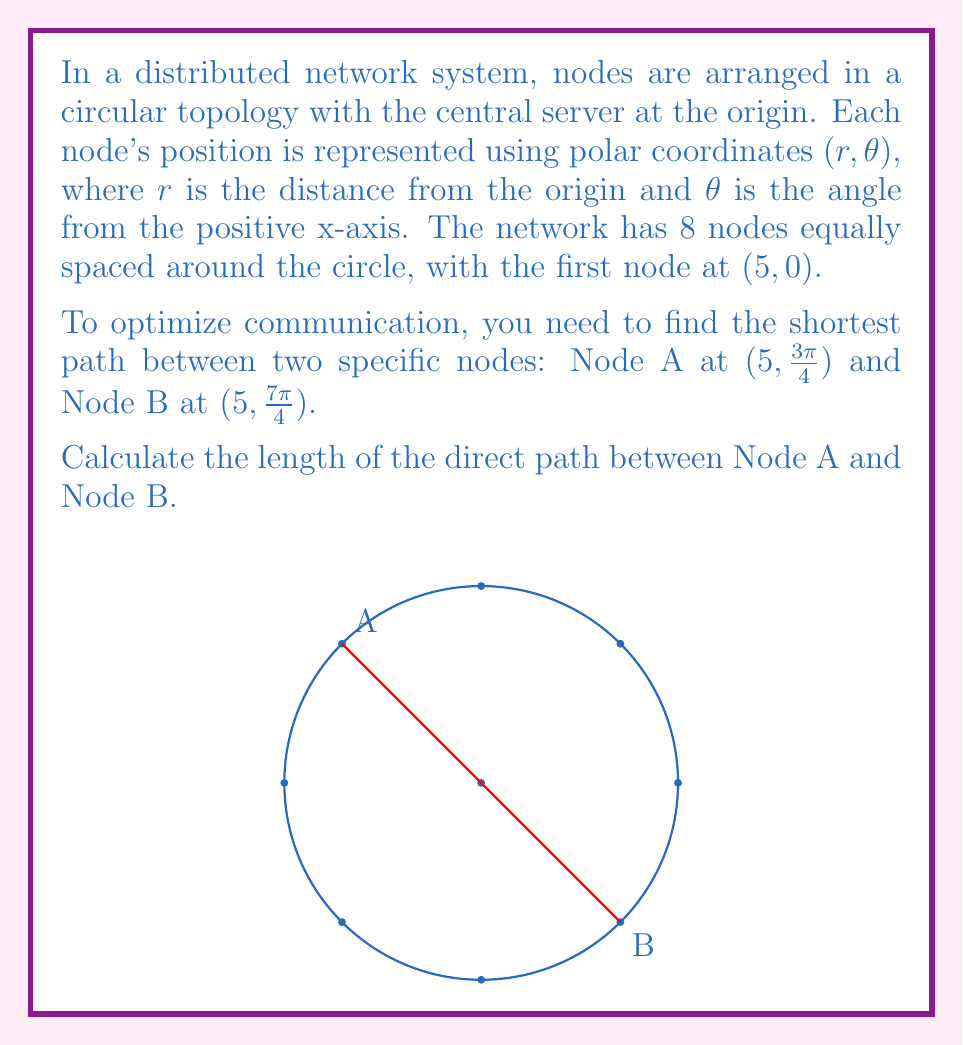Give your solution to this math problem. To solve this problem, we'll use the law of cosines, which is ideal for finding distances in polar coordinate systems. The steps are as follows:

1) In polar coordinates, the law of cosines states that for two points $(r_1, \theta_1)$ and $(r_2, \theta_2)$, the distance $d$ between them is:

   $$d^2 = r_1^2 + r_2^2 - 2r_1r_2 \cos(\theta_2 - \theta_1)$$

2) In our case:
   $r_1 = r_2 = 5$ (both nodes are on the same circle)
   $\theta_1 = \frac{3\pi}{4}$
   $\theta_2 = \frac{7\pi}{4}$

3) Let's calculate $\theta_2 - \theta_1$:
   $$\frac{7\pi}{4} - \frac{3\pi}{4} = \frac{4\pi}{4} = \pi$$

4) Now, let's substitute these values into the law of cosines:

   $$d^2 = 5^2 + 5^2 - 2(5)(5) \cos(\pi)$$

5) Simplify:
   $$d^2 = 25 + 25 - 50 \cos(\pi)$$

6) Recall that $\cos(\pi) = -1$:
   $$d^2 = 25 + 25 - 50(-1) = 25 + 25 + 50 = 100$$

7) Take the square root of both sides:
   $$d = \sqrt{100} = 10$$

Therefore, the direct distance between Node A and Node B is 10 units.
Answer: 10 units 